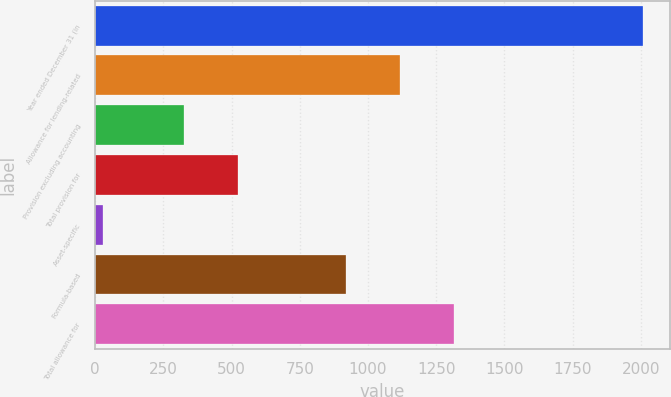<chart> <loc_0><loc_0><loc_500><loc_500><bar_chart><fcel>Year ended December 31 (in<fcel>Allowance for lending-related<fcel>Provision excluding accounting<fcel>Total provision for<fcel>Asset-specific<fcel>Formula-based<fcel>Total allowance for<nl><fcel>2007<fcel>1117.6<fcel>326<fcel>523.9<fcel>28<fcel>919.7<fcel>1315.5<nl></chart> 